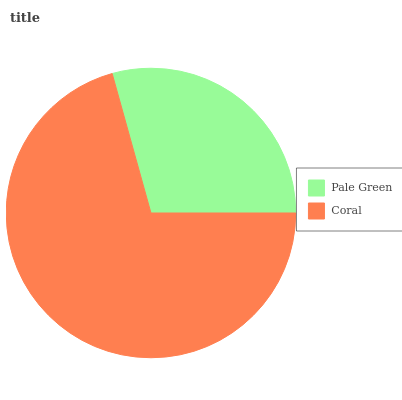Is Pale Green the minimum?
Answer yes or no. Yes. Is Coral the maximum?
Answer yes or no. Yes. Is Coral the minimum?
Answer yes or no. No. Is Coral greater than Pale Green?
Answer yes or no. Yes. Is Pale Green less than Coral?
Answer yes or no. Yes. Is Pale Green greater than Coral?
Answer yes or no. No. Is Coral less than Pale Green?
Answer yes or no. No. Is Coral the high median?
Answer yes or no. Yes. Is Pale Green the low median?
Answer yes or no. Yes. Is Pale Green the high median?
Answer yes or no. No. Is Coral the low median?
Answer yes or no. No. 